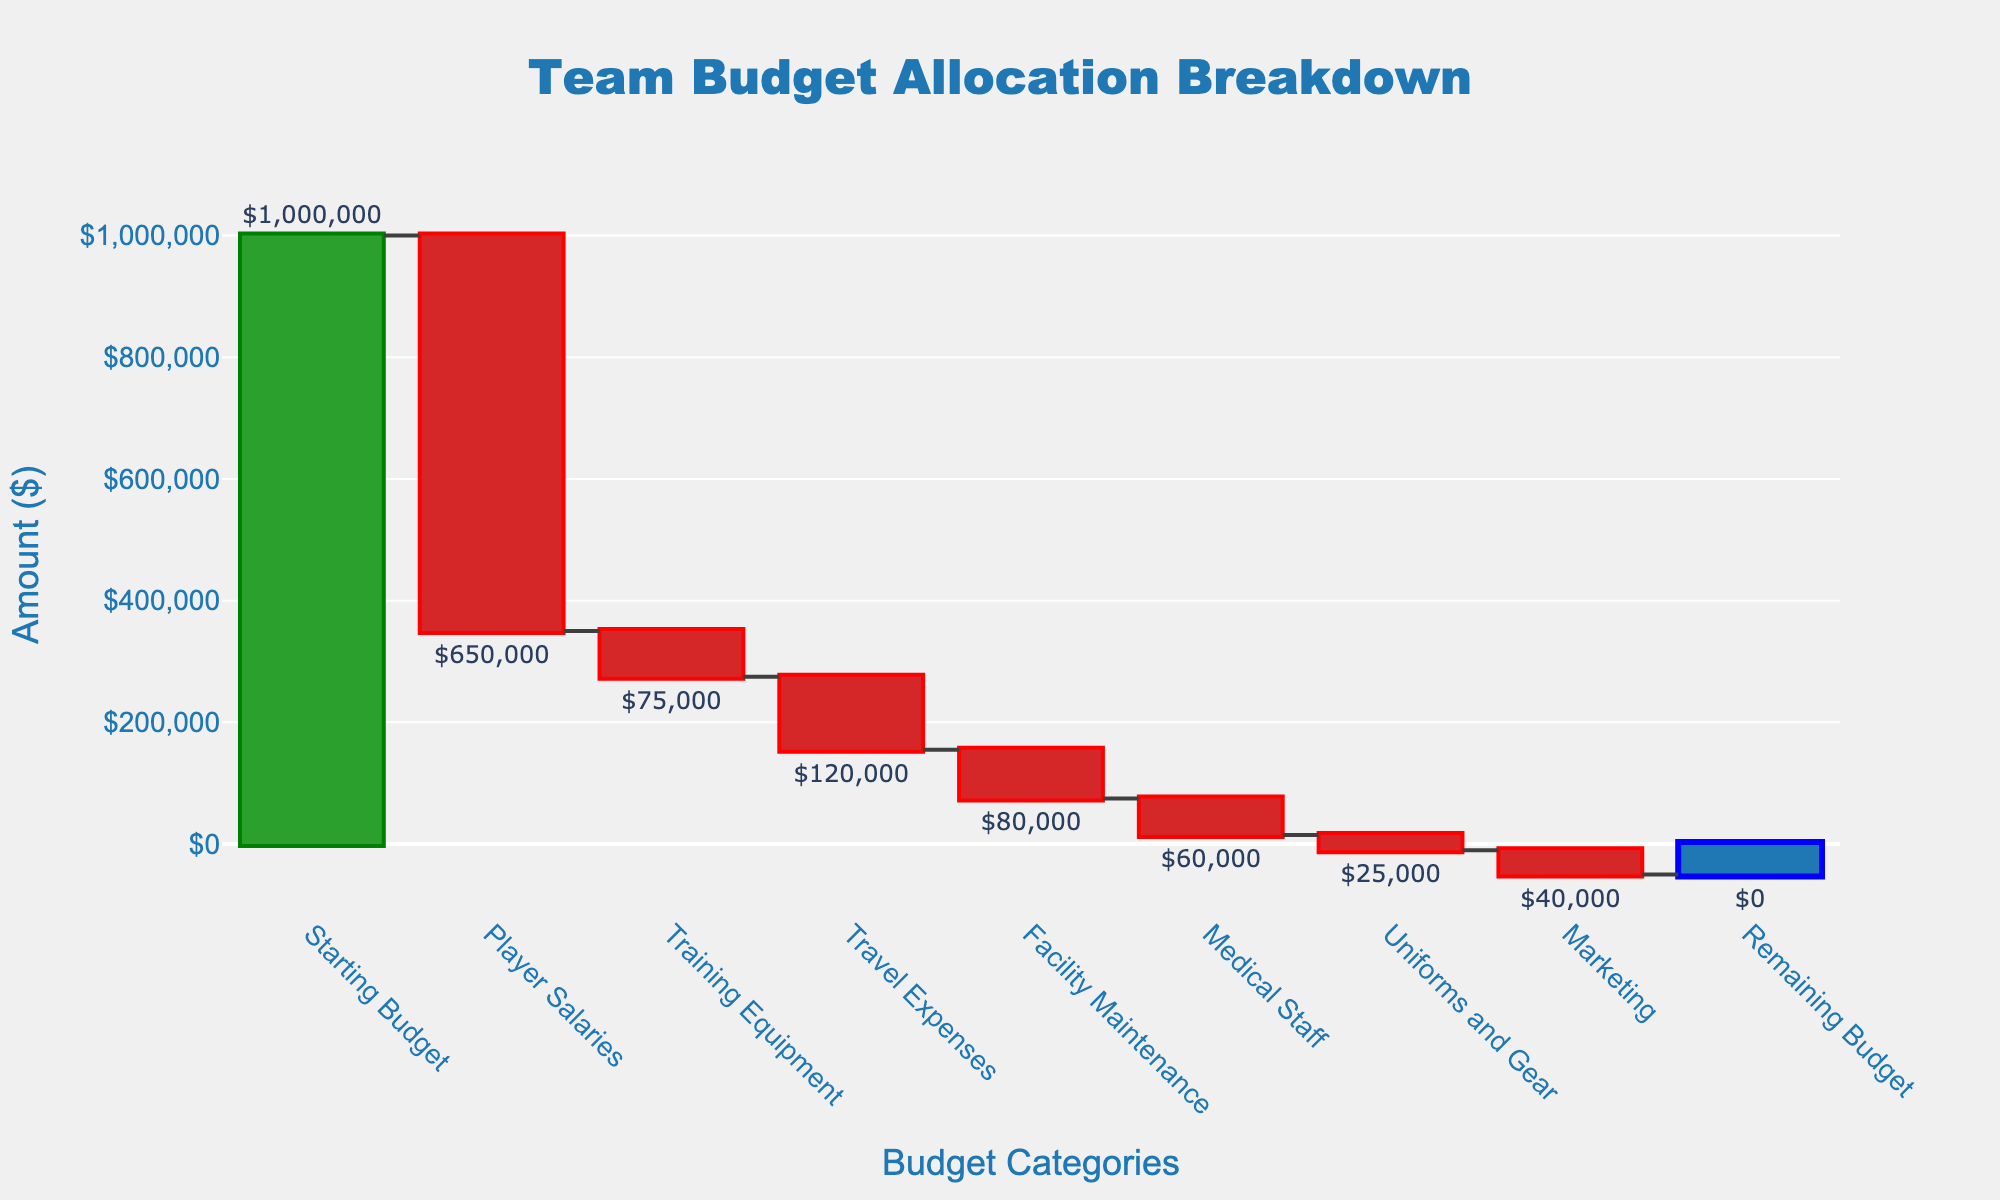What is the total starting budget for the team? The title of the chart is "Team Budget Allocation Breakdown" and the first category is labeled "Starting Budget" with a value indicating $1,000,000.
Answer: $1,000,000 Which expense category has the highest allocation? In the waterfall chart, the highest downward step represents the category with the most significant expense. "Player Salaries" has the largest drop with a value of -$650,000.
Answer: Player Salaries How much is allocated to Training Equipment? The chart shows a label for "Training Equipment" with an indicated value of -$75,000.
Answer: $75,000 Compare the allocations for Travel Expenses and Facility Maintenance. Which one is higher? By comparing the heights of the steps in the waterfall chart for "Travel Expenses" (-$120,000) and "Facility Maintenance" (-$80,000), it's clear that "Travel Expenses" is higher.
Answer: Travel Expenses How much is the remaining budget after all expenses? According to the waterfall chart, the final category labeled "Remaining Budget" has a value of $0, which indicates the remaining budget after all allocations.
Answer: $0 What is the total amount spent on Medical Staff and Uniforms and Gear combined? Add the allocated amounts for "Medical Staff" (-$60,000) and "Uniforms and Gear" (-$25,000): $60,000 + $25,000 = $85,000.
Answer: $85,000 Explain the color coding used in the chart for visual representation. The colors are used to indicate different types of changes: green for increases, red for decreases, and blue for the total/remaining value. The only increase is the starting budget (green), and all expenses (negative allocations) are shown in red. The remaining budget is shown in blue.
Answer: Green for increases, red for decreases, blue for total/remaining value What category results in the smallest reduction from the starting budget? The chart shows that "Uniforms and Gear" has the smallest downward step with a value of -$25,000.
Answer: Uniforms and Gear 